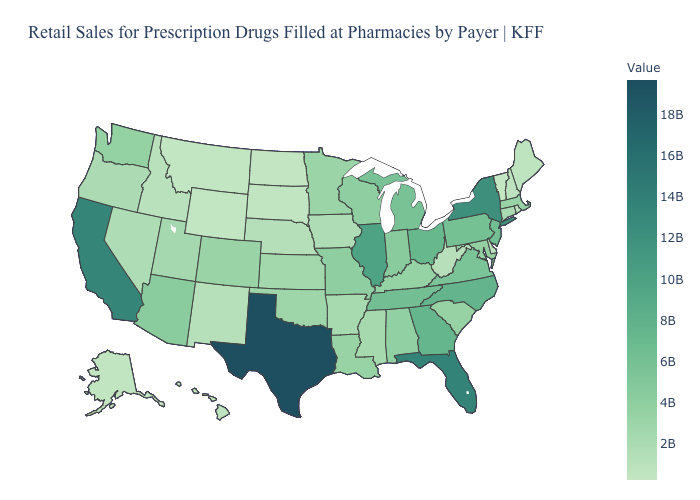Is the legend a continuous bar?
Quick response, please. Yes. Does the map have missing data?
Keep it brief. No. Among the states that border North Carolina , which have the highest value?
Be succinct. Georgia. Does the map have missing data?
Answer briefly. No. Which states have the lowest value in the West?
Quick response, please. Wyoming. 